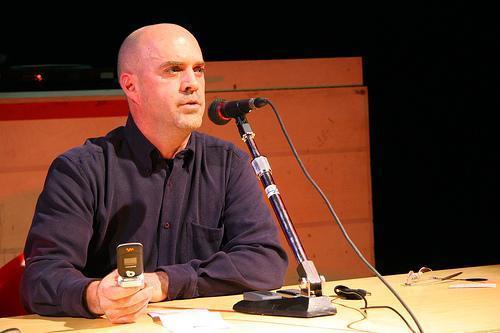How many cellphones are in the picture?
Give a very brief answer. 1. How many pairs of glasses are on the table?
Give a very brief answer. 1. How many of the man's buttons can be seen?
Give a very brief answer. 2. 